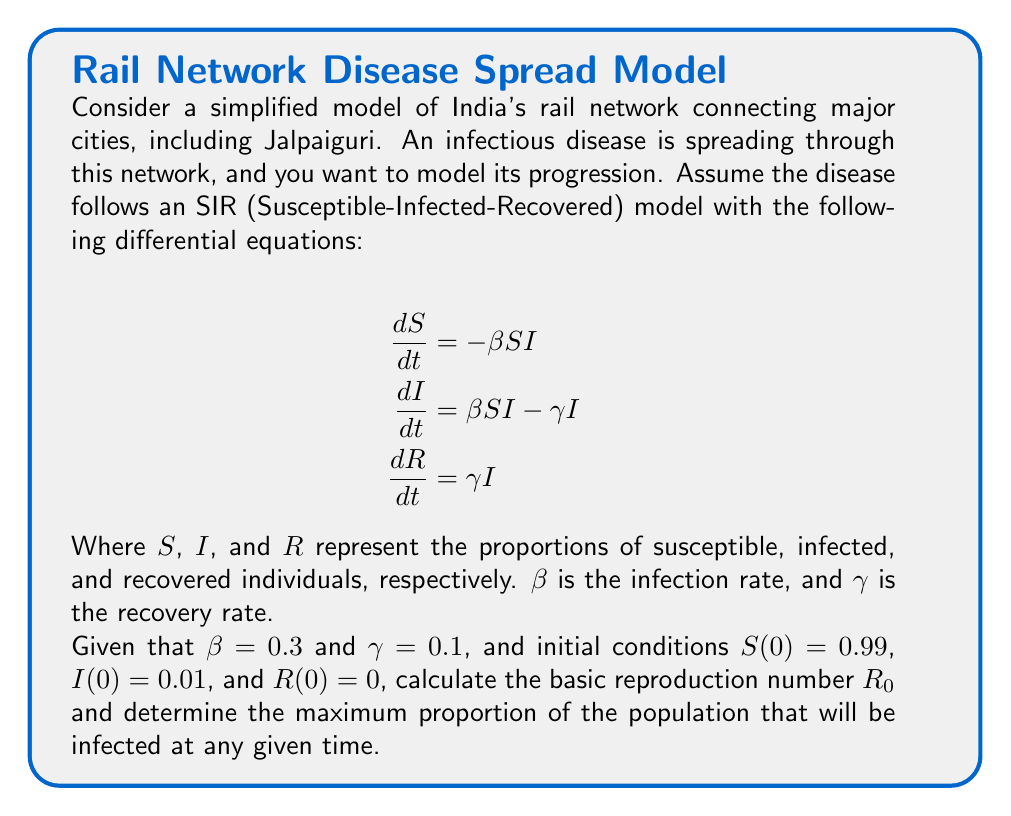Can you answer this question? To solve this problem, we'll follow these steps:

1. Calculate the basic reproduction number $R_0$
2. Find the equation for the maximum proportion of infected individuals
3. Solve for the maximum proportion of infected individuals

Step 1: Calculate $R_0$

The basic reproduction number $R_0$ is defined as the average number of secondary infections caused by one infected individual in a completely susceptible population. For the SIR model, it is given by:

$$R_0 = \frac{\beta}{\gamma}$$

Substituting the given values:

$$R_0 = \frac{0.3}{0.1} = 3$$

Step 2: Find the equation for the maximum proportion of infected individuals

To find the maximum proportion of infected individuals, we need to find when $\frac{dI}{dt} = 0$. From the second differential equation:

$$\frac{dI}{dt} = \beta SI - \gamma I = 0$$

Solving for $S$:

$$\beta SI = \gamma I$$
$$S = \frac{\gamma}{\beta} = \frac{1}{R_0}$$

This means that the maximum number of infected individuals occurs when $S = \frac{1}{R_0}$.

Step 3: Solve for the maximum proportion of infected individuals

We can use the conservation of total population principle: $S + I + R = 1$. At the start of the epidemic, $R(0) = 0$, so we can write:

$$S + I = 1 - R$$

At the peak of the epidemic, $S = \frac{1}{R_0}$, so:

$$\frac{1}{R_0} + I_{max} = 1 - R$$

We also know that $R$ can be expressed in terms of $S$:

$$R = 1 - S - \frac{1}{\beta} \ln(S) + \frac{1}{\beta} \ln(S(0))$$

Substituting $S = \frac{1}{R_0}$ and the initial condition $S(0) = 0.99$:

$$R = 1 - \frac{1}{R_0} - \frac{1}{\beta} \ln(\frac{1}{R_0}) + \frac{1}{\beta} \ln(0.99)$$

Now we can solve for $I_{max}$:

$$I_{max} = 1 - \frac{1}{R_0} - R$$
$$I_{max} = 1 - \frac{1}{R_0} - (1 - \frac{1}{R_0} - \frac{1}{\beta} \ln(\frac{1}{R_0}) + \frac{1}{\beta} \ln(0.99))$$
$$I_{max} = \frac{1}{\beta} \ln(\frac{1}{R_0}) - \frac{1}{\beta} \ln(0.99)$$

Substituting the values $R_0 = 3$ and $\beta = 0.3$:

$$I_{max} = \frac{1}{0.3} \ln(\frac{1}{3}) - \frac{1}{0.3} \ln(0.99)$$
$$I_{max} \approx 0.5396$$
Answer: The basic reproduction number $R_0 = 3$, and the maximum proportion of the population that will be infected at any given time is approximately 0.5396 or 53.96%. 